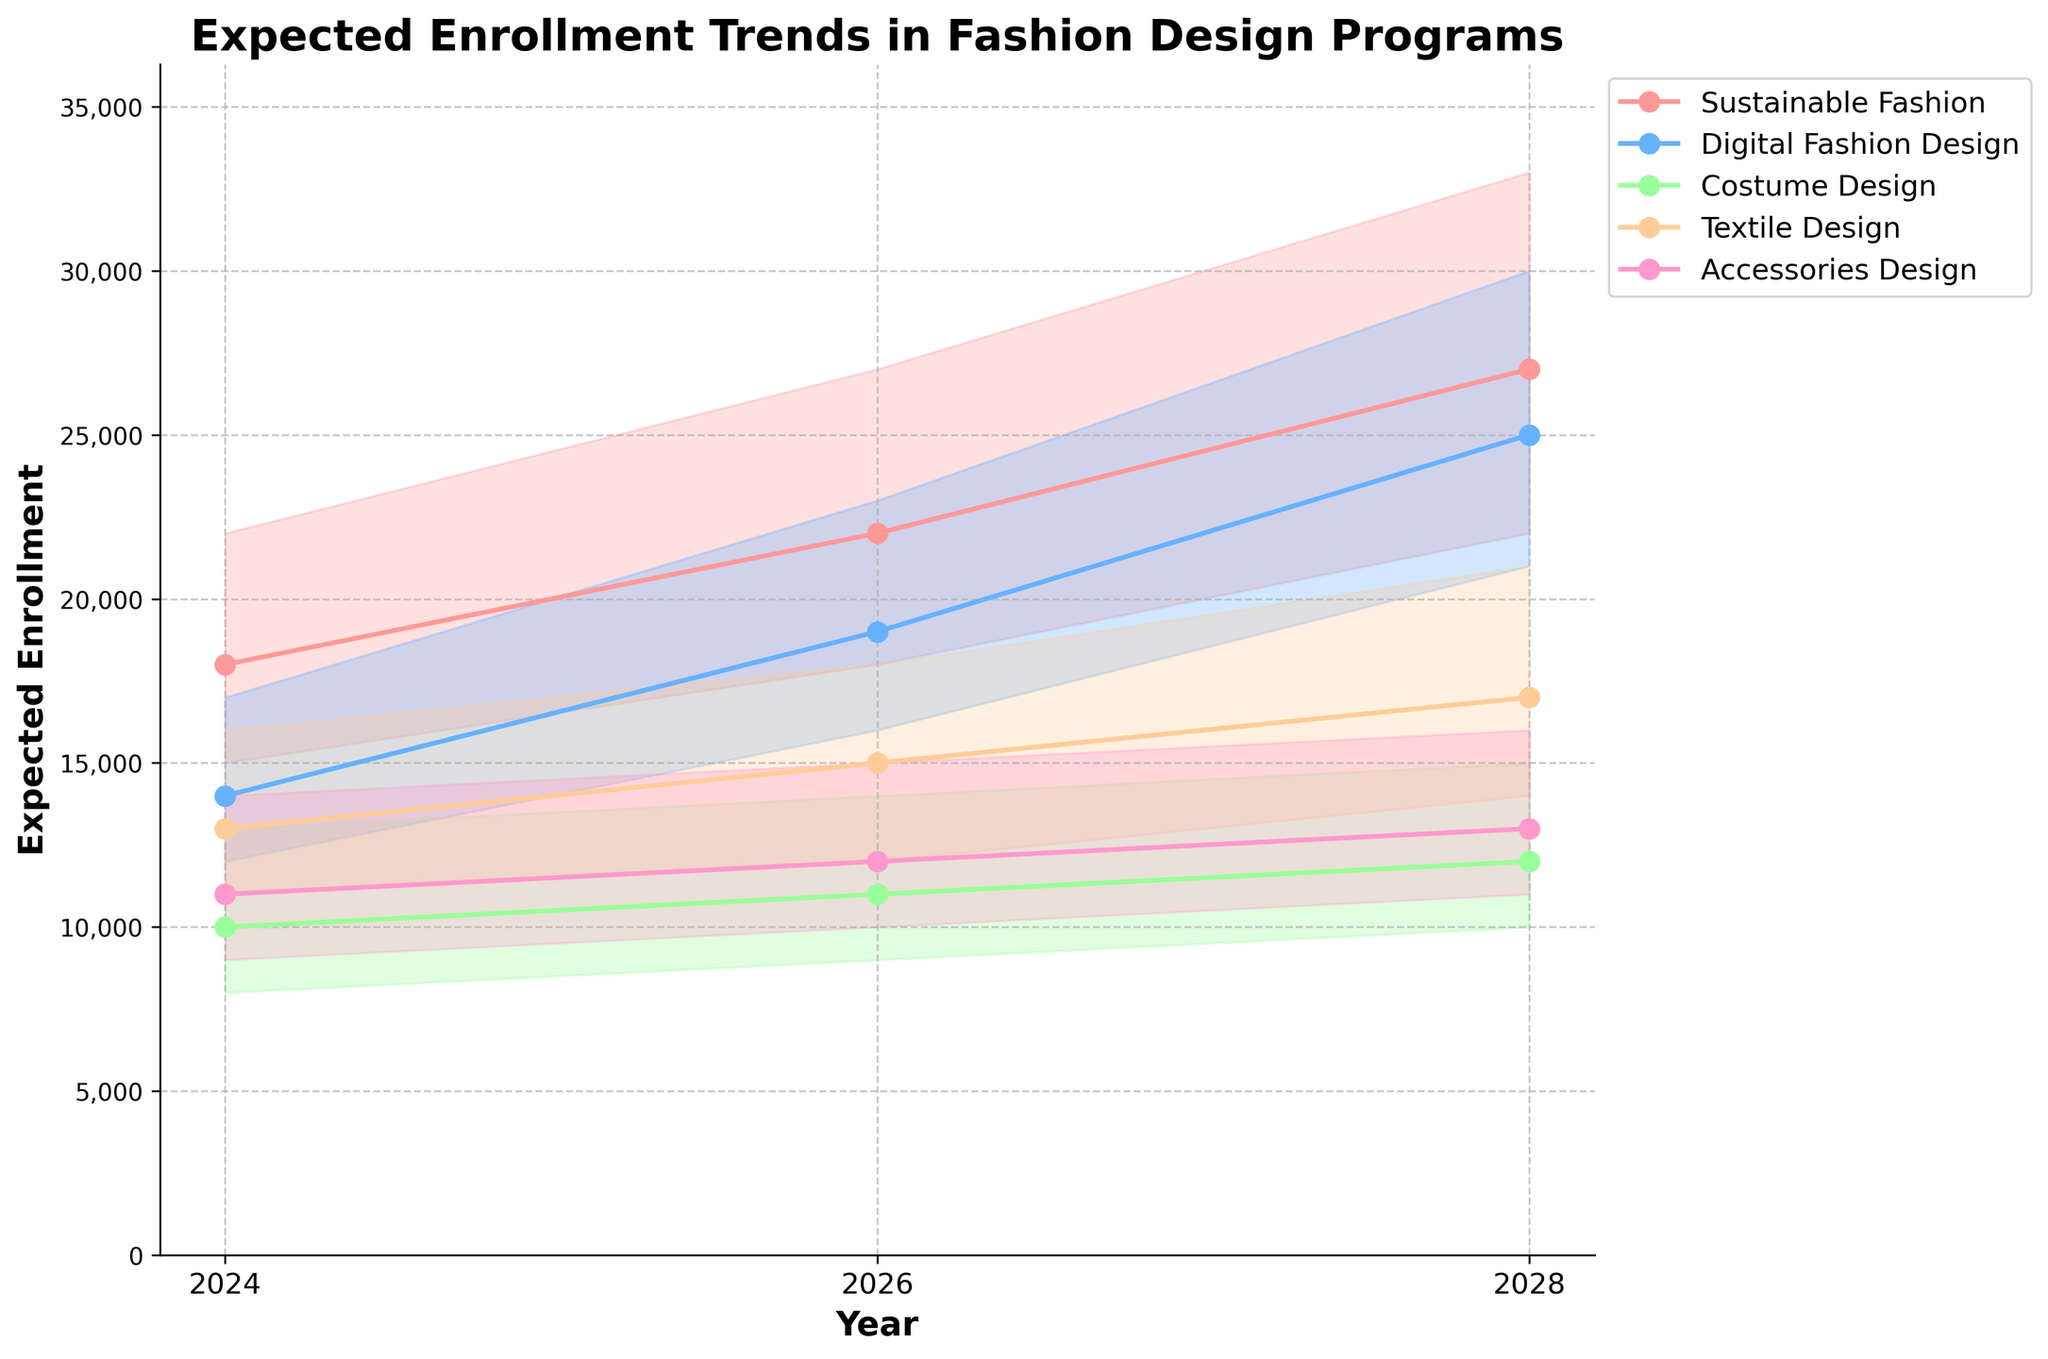What is the title of the chart? The title of the chart is usually found at the top of the figure, typically in a larger and bolder font than the rest of the text. Here, it reads "Expected Enrollment Trends in Fashion Design Programs".
Answer: Expected Enrollment Trends in Fashion Design Programs How many specializations are shown in the chart? By visually examining the legend, we see various colored markers with labels corresponding to different specializations. There are five labels in total: "Sustainable Fashion", "Digital Fashion Design", "Costume Design", "Textile Design", and "Accessories Design".
Answer: 5 Which specialization has the highest "Most Likely" estimate in 2028? To determine this, look for the year 2028 on the x-axis and check the "Most Likely" value lines for each specialization. The highest value corresponds to "Digital Fashion Design".
Answer: Digital Fashion Design What is the expected enrollment range for Accessories Design in 2024? Locate "Accessories Design" in the legend, then trace its color to 2024 on the x-axis. The range is spread between the 'Low Estimate' and 'High Estimate', which are 9000 and 14000 respectively.
Answer: 9000 to 14000 Compare the "Most Likely" estimates for Sustainable Fashion and Digital Fashion Design in 2026. Which one is higher? By looking at the "Most Likely" lines for both specializations in 2026, we see Sustainable Fashion has a "Most Likely" estimate of 22000, while Digital Fashion Design has 19000. Therefore, Sustainable Fashion is higher.
Answer: Sustainable Fashion Calculate the average "Most Likely" estimate for Textile Design across all years shown. First, find the "Most Likely" estimates for Textile Design in the years 2024, 2026, and 2028: 13000, 15000, and 17000 respectively. The average is calculated as (13000 + 15000 + 17000) / 3 = 45000 / 3 = 15000.
Answer: 15000 By how much does the "Most Likely" estimate for Sustainable Fashion increase from 2024 to 2028? The "Most Likely" estimate for Sustainable Fashion is 18000 in 2024 and 27000 in 2028. The increase is found by subtracting the 2024 value from the 2028 value: 27000 - 18000 = 9000.
Answer: 9000 Which year has the largest expected enrollment range for Costume Design, and what is the range? Examine the width between 'Low Estimate' and 'High Estimate' for Costume Design in each year. In 2028, it ranges from 10000 to 15000, the largest spread being 5000.
Answer: 2028, range is 5000 Is the enrollment trend for Accessories Design increasing, decreasing, or stable? Observing the "Most Likely" line for Accessories Design over the years 2024, 2026, and 2028, it shows an increasing trend, moving from 11000 to 12000 to 13000.
Answer: Increasing 